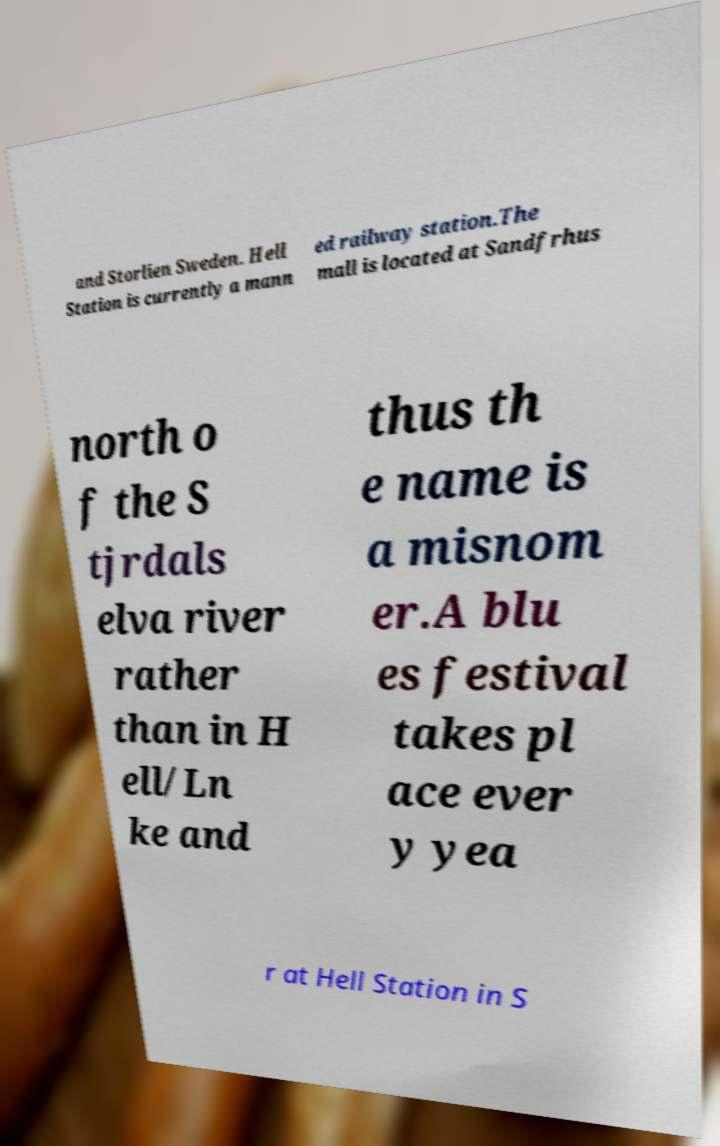There's text embedded in this image that I need extracted. Can you transcribe it verbatim? and Storlien Sweden. Hell Station is currently a mann ed railway station.The mall is located at Sandfrhus north o f the S tjrdals elva river rather than in H ell/Ln ke and thus th e name is a misnom er.A blu es festival takes pl ace ever y yea r at Hell Station in S 